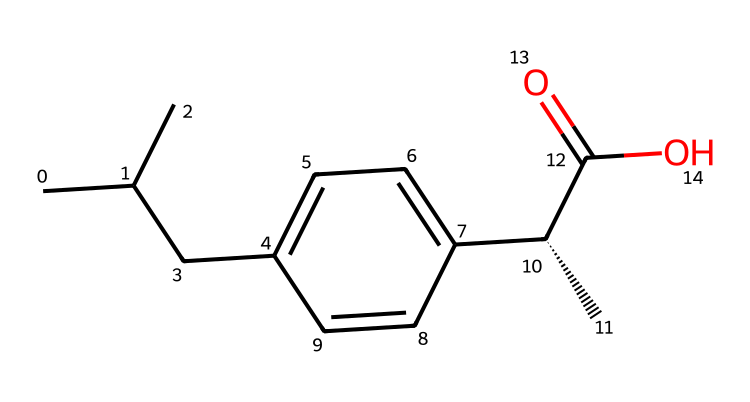How many carbon atoms are in this compound? By examining the SMILES representation, I can count the 'C' characters, noting that each represents a carbon atom. The branched alkyl groups and the benzene ring are made up of carbon atoms, totaling to 13 carbon atoms.
Answer: 13 What functional group is present in this compound? Looking at the chemical structure, the segment ‘C(=O)O’ indicates the presence of a carboxylic acid functional group. This is characterized by a carbon atom double-bonded to an oxygen atom (carbonyl) and also single-bonded to a hydroxyl group (OH).
Answer: carboxylic acid What is the root name of this chemical? The core structure shows the presence of an aromatic ring associated with the ‘-profen’ suffix, which indicates that this chemical is a derivative of propionic acid, commonly known as ibuprofen. Thus, the root name is Ibuprofen.
Answer: Ibuprofen Does this compound include a chiral center? In the SMILES code, the notation ‘[C@@H]’ indicates that there is a chiral center at that carbon atom, which has four different substituents attached to it, allowing for non-superimposable mirror images.
Answer: Yes What type of drug classification does this compound belong to? This compound is classified as a nonsteroidal anti-inflammatory drug (NSAID) based on its structure and function. NSAIDs are known for their ability to reduce inflammation and relieve pain without the use of steroids.
Answer: NSAID What type of interactions would the hydroxyl group promote? The presence of the hydroxyl group (-OH) suggests that this compound can form hydrogen bonds due to the polarity of the -OH group, facilitating interactions with water and other polar molecules.
Answer: Hydrogen bonds What is the significance of the decimal notation in this SMILES? The ‘@’ symbol in the SMILES string indicates chirality at that particular carbon atom, demonstrating that there are two different spatial arrangements possible at this position, which is important for understanding the drug's activity and metabolism.
Answer: Chirality 